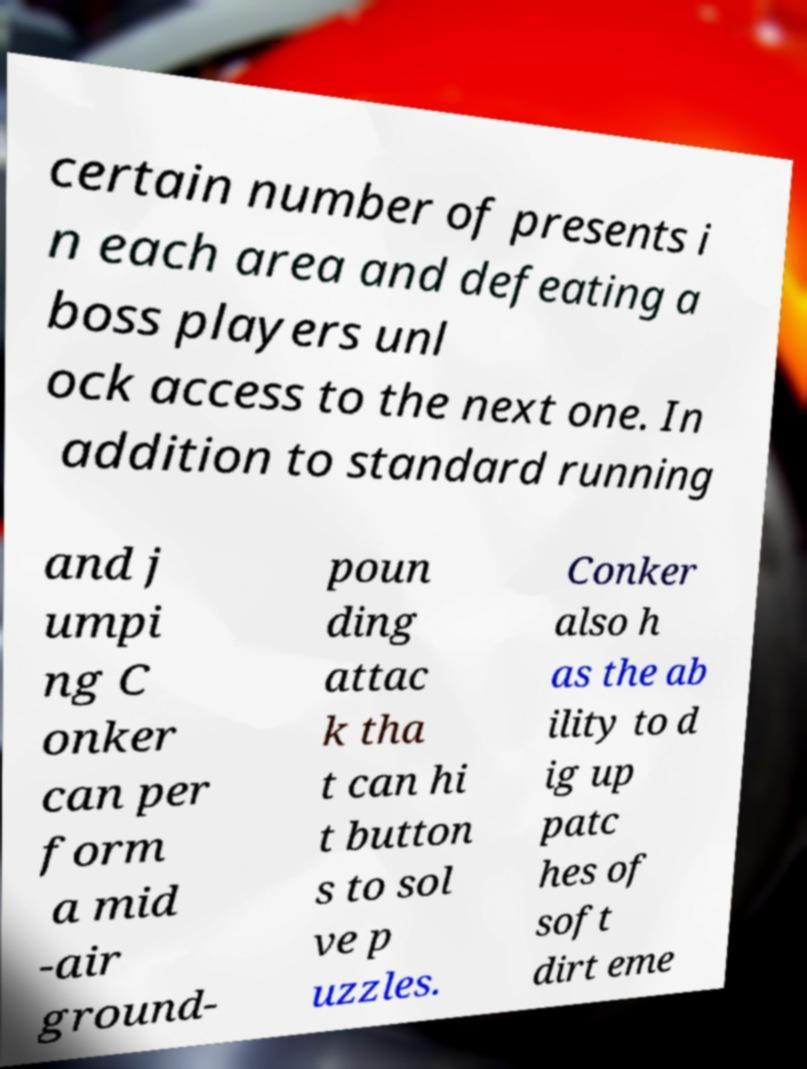Please identify and transcribe the text found in this image. certain number of presents i n each area and defeating a boss players unl ock access to the next one. In addition to standard running and j umpi ng C onker can per form a mid -air ground- poun ding attac k tha t can hi t button s to sol ve p uzzles. Conker also h as the ab ility to d ig up patc hes of soft dirt eme 